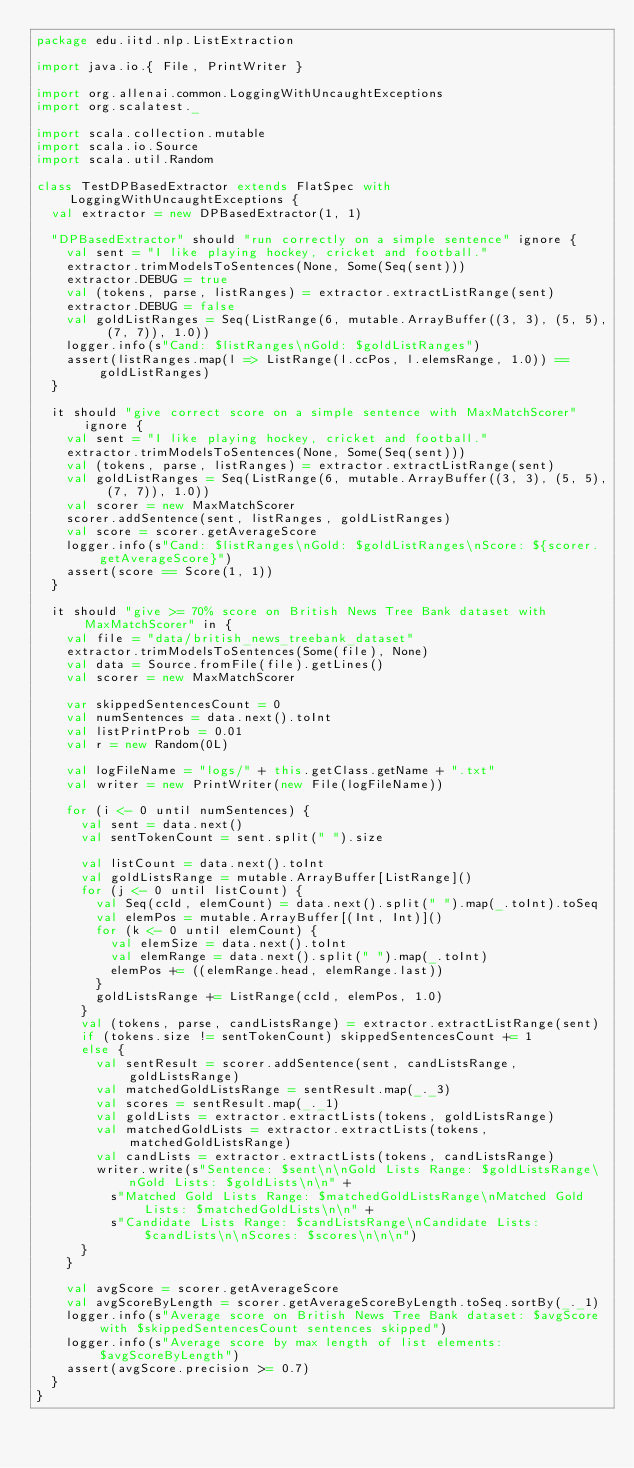Convert code to text. <code><loc_0><loc_0><loc_500><loc_500><_Scala_>package edu.iitd.nlp.ListExtraction

import java.io.{ File, PrintWriter }

import org.allenai.common.LoggingWithUncaughtExceptions
import org.scalatest._

import scala.collection.mutable
import scala.io.Source
import scala.util.Random

class TestDPBasedExtractor extends FlatSpec with LoggingWithUncaughtExceptions {
  val extractor = new DPBasedExtractor(1, 1)

  "DPBasedExtractor" should "run correctly on a simple sentence" ignore {
    val sent = "I like playing hockey, cricket and football."
    extractor.trimModelsToSentences(None, Some(Seq(sent)))
    extractor.DEBUG = true
    val (tokens, parse, listRanges) = extractor.extractListRange(sent)
    extractor.DEBUG = false
    val goldListRanges = Seq(ListRange(6, mutable.ArrayBuffer((3, 3), (5, 5), (7, 7)), 1.0))
    logger.info(s"Cand: $listRanges\nGold: $goldListRanges")
    assert(listRanges.map(l => ListRange(l.ccPos, l.elemsRange, 1.0)) == goldListRanges)
  }

  it should "give correct score on a simple sentence with MaxMatchScorer" ignore {
    val sent = "I like playing hockey, cricket and football."
    extractor.trimModelsToSentences(None, Some(Seq(sent)))
    val (tokens, parse, listRanges) = extractor.extractListRange(sent)
    val goldListRanges = Seq(ListRange(6, mutable.ArrayBuffer((3, 3), (5, 5), (7, 7)), 1.0))
    val scorer = new MaxMatchScorer
    scorer.addSentence(sent, listRanges, goldListRanges)
    val score = scorer.getAverageScore
    logger.info(s"Cand: $listRanges\nGold: $goldListRanges\nScore: ${scorer.getAverageScore}")
    assert(score == Score(1, 1))
  }

  it should "give >= 70% score on British News Tree Bank dataset with MaxMatchScorer" in {
    val file = "data/british_news_treebank_dataset"
    extractor.trimModelsToSentences(Some(file), None)
    val data = Source.fromFile(file).getLines()
    val scorer = new MaxMatchScorer

    var skippedSentencesCount = 0
    val numSentences = data.next().toInt
    val listPrintProb = 0.01
    val r = new Random(0L)

    val logFileName = "logs/" + this.getClass.getName + ".txt"
    val writer = new PrintWriter(new File(logFileName))

    for (i <- 0 until numSentences) {
      val sent = data.next()
      val sentTokenCount = sent.split(" ").size

      val listCount = data.next().toInt
      val goldListsRange = mutable.ArrayBuffer[ListRange]()
      for (j <- 0 until listCount) {
        val Seq(ccId, elemCount) = data.next().split(" ").map(_.toInt).toSeq
        val elemPos = mutable.ArrayBuffer[(Int, Int)]()
        for (k <- 0 until elemCount) {
          val elemSize = data.next().toInt
          val elemRange = data.next().split(" ").map(_.toInt)
          elemPos += ((elemRange.head, elemRange.last))
        }
        goldListsRange += ListRange(ccId, elemPos, 1.0)
      }
      val (tokens, parse, candListsRange) = extractor.extractListRange(sent)
      if (tokens.size != sentTokenCount) skippedSentencesCount += 1
      else {
        val sentResult = scorer.addSentence(sent, candListsRange, goldListsRange)
        val matchedGoldListsRange = sentResult.map(_._3)
        val scores = sentResult.map(_._1)
        val goldLists = extractor.extractLists(tokens, goldListsRange)
        val matchedGoldLists = extractor.extractLists(tokens, matchedGoldListsRange)
        val candLists = extractor.extractLists(tokens, candListsRange)
        writer.write(s"Sentence: $sent\n\nGold Lists Range: $goldListsRange\nGold Lists: $goldLists\n\n" +
          s"Matched Gold Lists Range: $matchedGoldListsRange\nMatched Gold Lists: $matchedGoldLists\n\n" +
          s"Candidate Lists Range: $candListsRange\nCandidate Lists: $candLists\n\nScores: $scores\n\n\n")
      }
    }

    val avgScore = scorer.getAverageScore
    val avgScoreByLength = scorer.getAverageScoreByLength.toSeq.sortBy(_._1)
    logger.info(s"Average score on British News Tree Bank dataset: $avgScore with $skippedSentencesCount sentences skipped")
    logger.info(s"Average score by max length of list elements: $avgScoreByLength")
    assert(avgScore.precision >= 0.7)
  }
}
</code> 